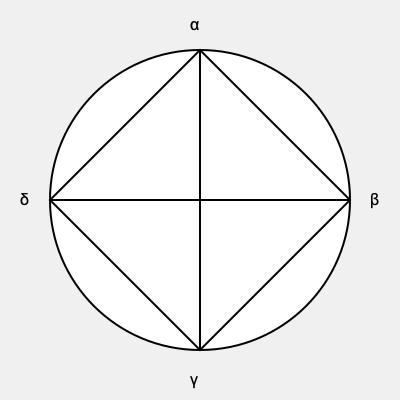In the context of Christian iconography, what theological concept does this diagram represent, and how do the Greek letters relate to its interpretation? To interpret this diagram in the context of Christian iconography, we need to follow these steps:

1. Recognize the basic structure: The diagram shows a circle with a cross inside, forming four quadrants.

2. Identify the symbol: This is known as a "Consecration Cross" or "Dedication Cross," commonly used in the consecration of churches.

3. Understand the symbolism of the circle: In Christian art, the circle often represents eternity, perfection, or God's infinite nature.

4. Interpret the cross: The cross symbolizes Christ's sacrifice and the four directions of the earth.

5. Analyze the Greek letters:
   α (alpha): The first letter of the Greek alphabet, symbolizing the beginning.
   β (beta): The second letter, representing creation or the physical world.
   γ (gamma): The third letter, often associated with the Holy Spirit.
   δ (delta): The fourth letter, can represent completion or the four corners of the earth.

6. Theological interpretation: This diagram represents the concept of God's all-encompassing nature and Christ's redemption of all creation. The Alpha (α) at the top represents God as the beginning, while the other letters symbolize various aspects of creation and divine intervention.

7. Liturgical significance: In church consecration, this symbol is often marked on walls or pillars, representing the sanctification of the space and its dedication to God's purposes.
Answer: God's omnipresence and Christ's universal redemption 